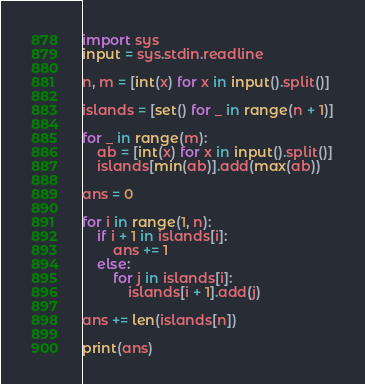<code> <loc_0><loc_0><loc_500><loc_500><_Python_>import sys
input = sys.stdin.readline

n, m = [int(x) for x in input().split()]

islands = [set() for _ in range(n + 1)]

for _ in range(m):
    ab = [int(x) for x in input().split()]
    islands[min(ab)].add(max(ab))

ans = 0

for i in range(1, n):
    if i + 1 in islands[i]:
        ans += 1
    else:
        for j in islands[i]:
            islands[i + 1].add(j)

ans += len(islands[n])

print(ans)
</code> 